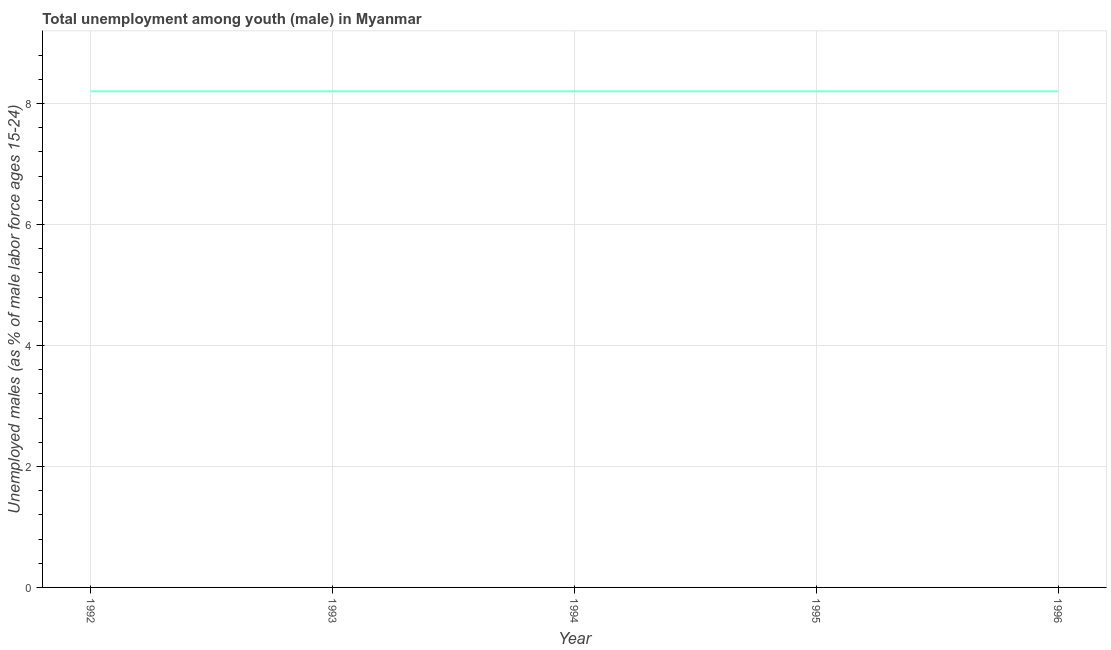What is the unemployed male youth population in 1993?
Your answer should be very brief. 8.2. Across all years, what is the maximum unemployed male youth population?
Your answer should be very brief. 8.2. Across all years, what is the minimum unemployed male youth population?
Give a very brief answer. 8.2. In which year was the unemployed male youth population minimum?
Make the answer very short. 1992. What is the sum of the unemployed male youth population?
Provide a succinct answer. 41. What is the average unemployed male youth population per year?
Your response must be concise. 8.2. What is the median unemployed male youth population?
Provide a succinct answer. 8.2. Do a majority of the years between 1995 and 1996 (inclusive) have unemployed male youth population greater than 5.2 %?
Your answer should be very brief. Yes. What is the ratio of the unemployed male youth population in 1993 to that in 1996?
Keep it short and to the point. 1. Is the difference between the unemployed male youth population in 1992 and 1996 greater than the difference between any two years?
Offer a terse response. Yes. What is the difference between the highest and the lowest unemployed male youth population?
Offer a terse response. 0. In how many years, is the unemployed male youth population greater than the average unemployed male youth population taken over all years?
Provide a short and direct response. 0. Does the unemployed male youth population monotonically increase over the years?
Make the answer very short. No. How many lines are there?
Provide a succinct answer. 1. How many years are there in the graph?
Your response must be concise. 5. Are the values on the major ticks of Y-axis written in scientific E-notation?
Your response must be concise. No. What is the title of the graph?
Provide a succinct answer. Total unemployment among youth (male) in Myanmar. What is the label or title of the Y-axis?
Ensure brevity in your answer.  Unemployed males (as % of male labor force ages 15-24). What is the Unemployed males (as % of male labor force ages 15-24) in 1992?
Offer a very short reply. 8.2. What is the Unemployed males (as % of male labor force ages 15-24) in 1993?
Your response must be concise. 8.2. What is the Unemployed males (as % of male labor force ages 15-24) of 1994?
Offer a terse response. 8.2. What is the Unemployed males (as % of male labor force ages 15-24) of 1995?
Give a very brief answer. 8.2. What is the Unemployed males (as % of male labor force ages 15-24) in 1996?
Give a very brief answer. 8.2. What is the difference between the Unemployed males (as % of male labor force ages 15-24) in 1992 and 1993?
Provide a succinct answer. 0. What is the difference between the Unemployed males (as % of male labor force ages 15-24) in 1992 and 1994?
Keep it short and to the point. 0. What is the difference between the Unemployed males (as % of male labor force ages 15-24) in 1992 and 1995?
Your response must be concise. 0. What is the difference between the Unemployed males (as % of male labor force ages 15-24) in 1993 and 1994?
Give a very brief answer. 0. What is the difference between the Unemployed males (as % of male labor force ages 15-24) in 1993 and 1995?
Your answer should be compact. 0. What is the difference between the Unemployed males (as % of male labor force ages 15-24) in 1994 and 1995?
Your answer should be very brief. 0. What is the ratio of the Unemployed males (as % of male labor force ages 15-24) in 1992 to that in 1994?
Offer a very short reply. 1. What is the ratio of the Unemployed males (as % of male labor force ages 15-24) in 1992 to that in 1996?
Give a very brief answer. 1. What is the ratio of the Unemployed males (as % of male labor force ages 15-24) in 1993 to that in 1994?
Your response must be concise. 1. What is the ratio of the Unemployed males (as % of male labor force ages 15-24) in 1993 to that in 1995?
Make the answer very short. 1. What is the ratio of the Unemployed males (as % of male labor force ages 15-24) in 1993 to that in 1996?
Offer a very short reply. 1. What is the ratio of the Unemployed males (as % of male labor force ages 15-24) in 1994 to that in 1996?
Keep it short and to the point. 1. 